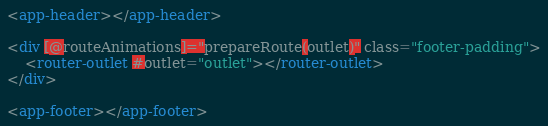Convert code to text. <code><loc_0><loc_0><loc_500><loc_500><_HTML_><app-header></app-header>

<div [@routeAnimations]="prepareRoute(outlet)" class="footer-padding">
    <router-outlet #outlet="outlet"></router-outlet>
</div>

<app-footer></app-footer>
</code> 